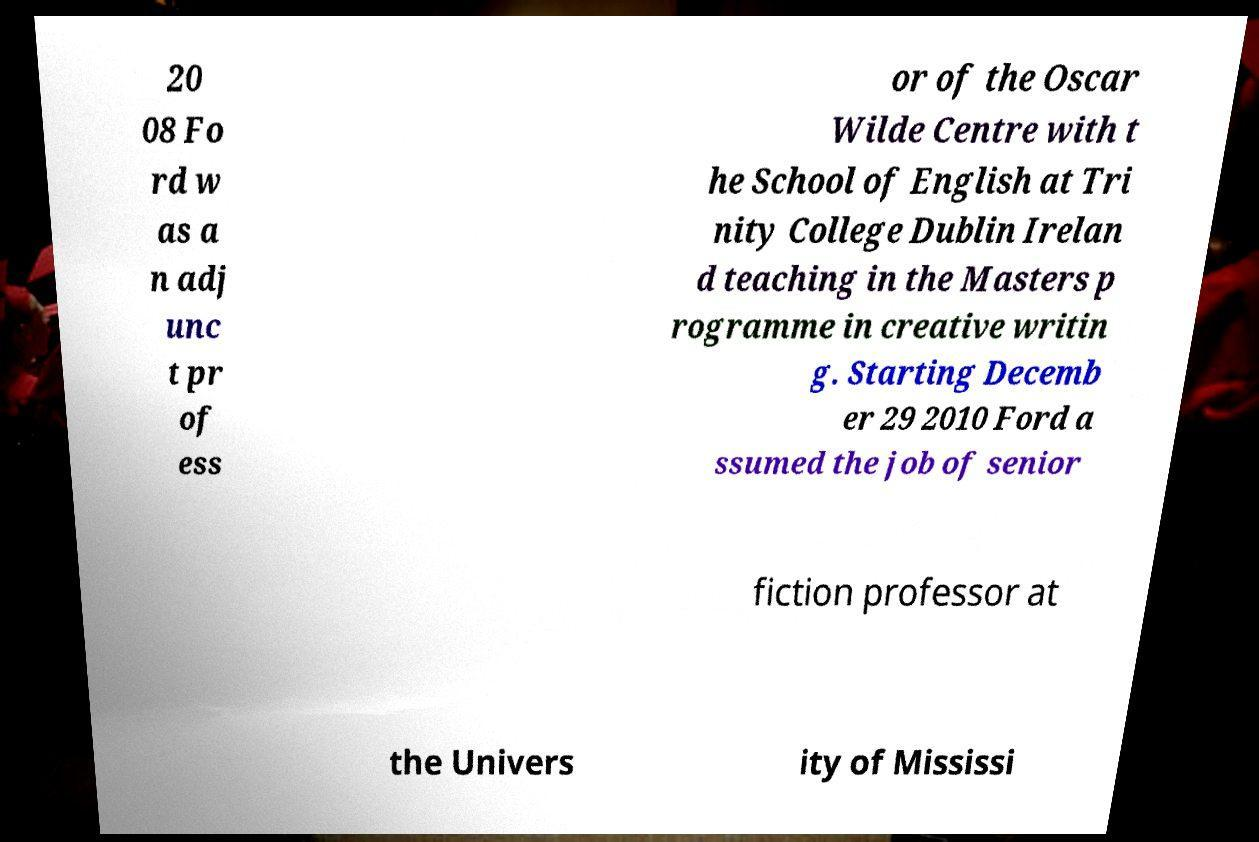For documentation purposes, I need the text within this image transcribed. Could you provide that? 20 08 Fo rd w as a n adj unc t pr of ess or of the Oscar Wilde Centre with t he School of English at Tri nity College Dublin Irelan d teaching in the Masters p rogramme in creative writin g. Starting Decemb er 29 2010 Ford a ssumed the job of senior fiction professor at the Univers ity of Mississi 